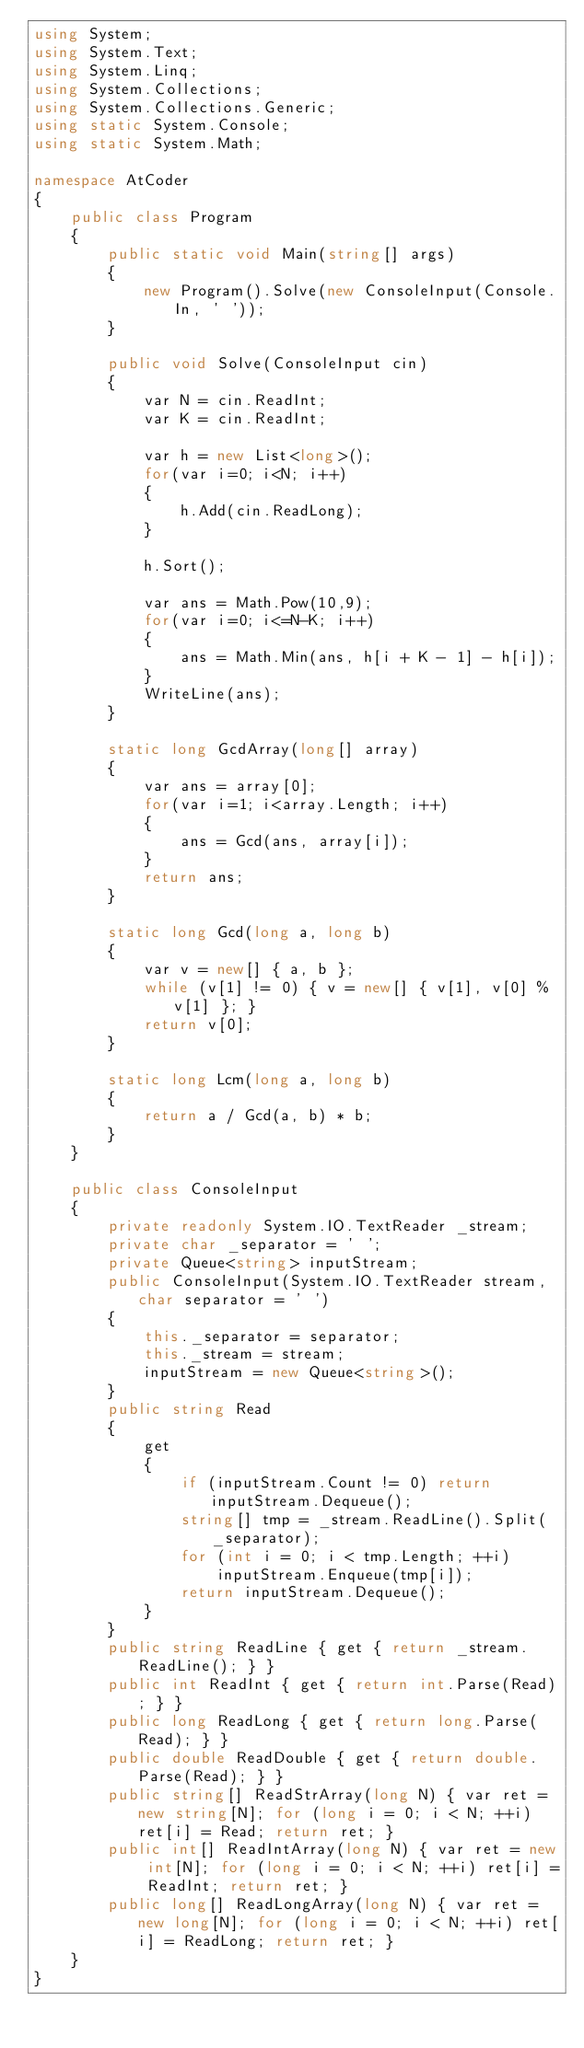<code> <loc_0><loc_0><loc_500><loc_500><_C#_>using System;
using System.Text;
using System.Linq;
using System.Collections;
using System.Collections.Generic;
using static System.Console;
using static System.Math;

namespace AtCoder
{
    public class Program
    {
        public static void Main(string[] args)
        {
            new Program().Solve(new ConsoleInput(Console.In, ' '));
        }

        public void Solve(ConsoleInput cin)
        {
            var N = cin.ReadInt;
            var K = cin.ReadInt;

            var h = new List<long>();
            for(var i=0; i<N; i++)
            {
                h.Add(cin.ReadLong);
            }

            h.Sort();

            var ans = Math.Pow(10,9);
            for(var i=0; i<=N-K; i++)
            {
                ans = Math.Min(ans, h[i + K - 1] - h[i]);
            }
            WriteLine(ans);
        }

        static long GcdArray(long[] array)
        {
            var ans = array[0];
            for(var i=1; i<array.Length; i++)
            {
                ans = Gcd(ans, array[i]);
            }
            return ans;
        }

        static long Gcd(long a, long b)
        {
            var v = new[] { a, b };
            while (v[1] != 0) { v = new[] { v[1], v[0] % v[1] }; }
            return v[0];
        }

        static long Lcm(long a, long b)
        {
            return a / Gcd(a, b) * b;
        }
    }

    public class ConsoleInput
    {
        private readonly System.IO.TextReader _stream;
        private char _separator = ' ';
        private Queue<string> inputStream;
        public ConsoleInput(System.IO.TextReader stream, char separator = ' ')
        {
            this._separator = separator;
            this._stream = stream;
            inputStream = new Queue<string>();
        }
        public string Read
        {
            get
            {
                if (inputStream.Count != 0) return inputStream.Dequeue();
                string[] tmp = _stream.ReadLine().Split(_separator);
                for (int i = 0; i < tmp.Length; ++i)
                    inputStream.Enqueue(tmp[i]);
                return inputStream.Dequeue();
            }
        }
        public string ReadLine { get { return _stream.ReadLine(); } }
        public int ReadInt { get { return int.Parse(Read); } }
        public long ReadLong { get { return long.Parse(Read); } }
        public double ReadDouble { get { return double.Parse(Read); } }
        public string[] ReadStrArray(long N) { var ret = new string[N]; for (long i = 0; i < N; ++i) ret[i] = Read; return ret; }
        public int[] ReadIntArray(long N) { var ret = new int[N]; for (long i = 0; i < N; ++i) ret[i] = ReadInt; return ret; }
        public long[] ReadLongArray(long N) { var ret = new long[N]; for (long i = 0; i < N; ++i) ret[i] = ReadLong; return ret; }
    }
}</code> 